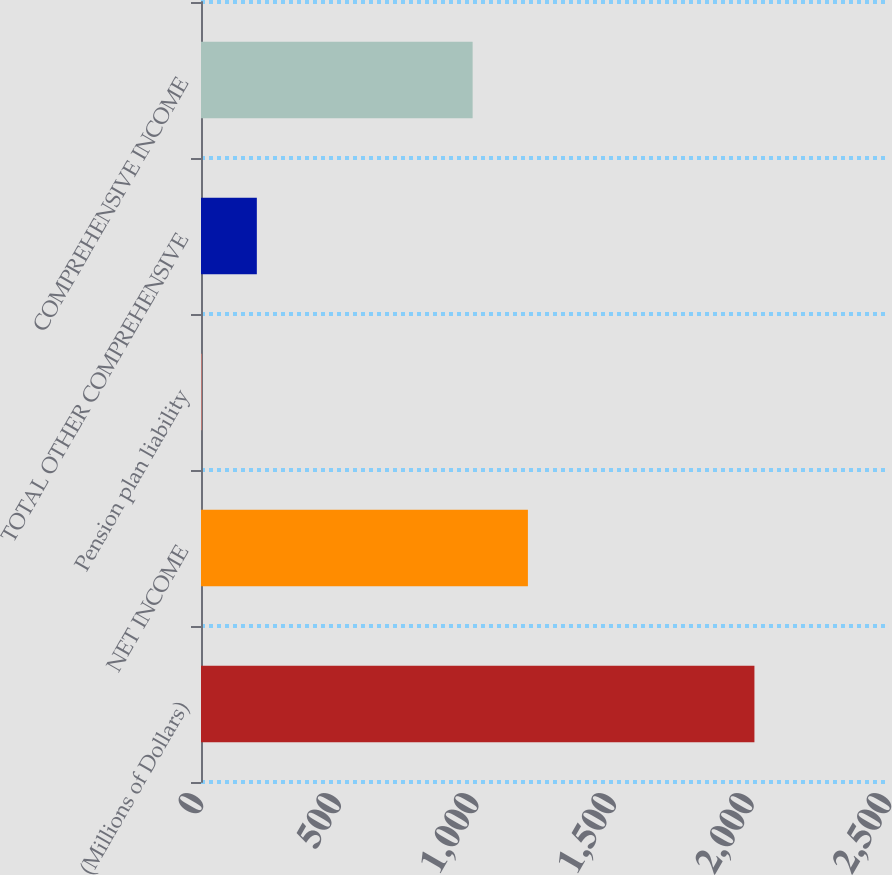Convert chart. <chart><loc_0><loc_0><loc_500><loc_500><bar_chart><fcel>(Millions of Dollars)<fcel>NET INCOME<fcel>Pension plan liability<fcel>TOTAL OTHER COMPREHENSIVE<fcel>COMPREHENSIVE INCOME<nl><fcel>2011<fcel>1187.9<fcel>2<fcel>202.9<fcel>987<nl></chart> 